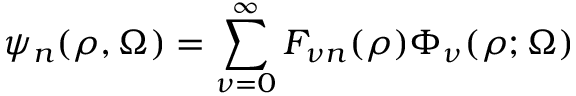<formula> <loc_0><loc_0><loc_500><loc_500>\psi _ { n } ( \rho , \Omega ) = \sum _ { \nu = 0 } ^ { \infty } F _ { \nu n } ( \rho ) \Phi _ { \nu } ( \rho ; \Omega )</formula> 